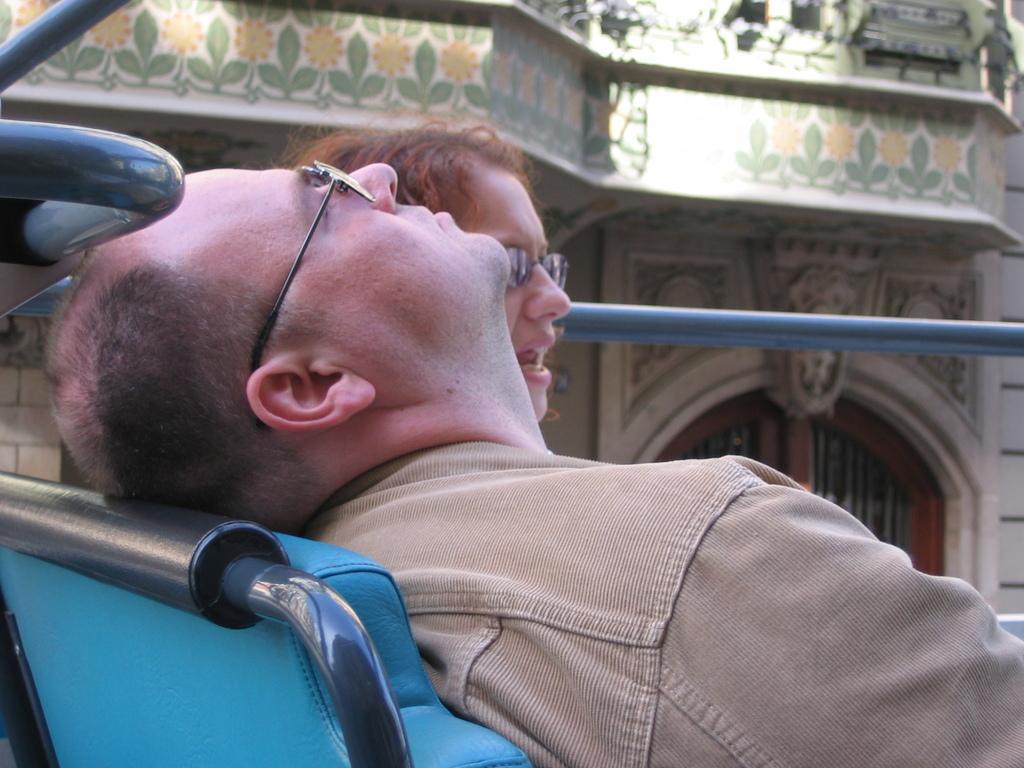How would you summarize this image in a sentence or two? In front of the image there is a man with spectacles and he is sitting on the seat. Beside him there is a lady with spectacles. And in front of the image there are rods. Behind them in the background there is a wall with designs and windows. 